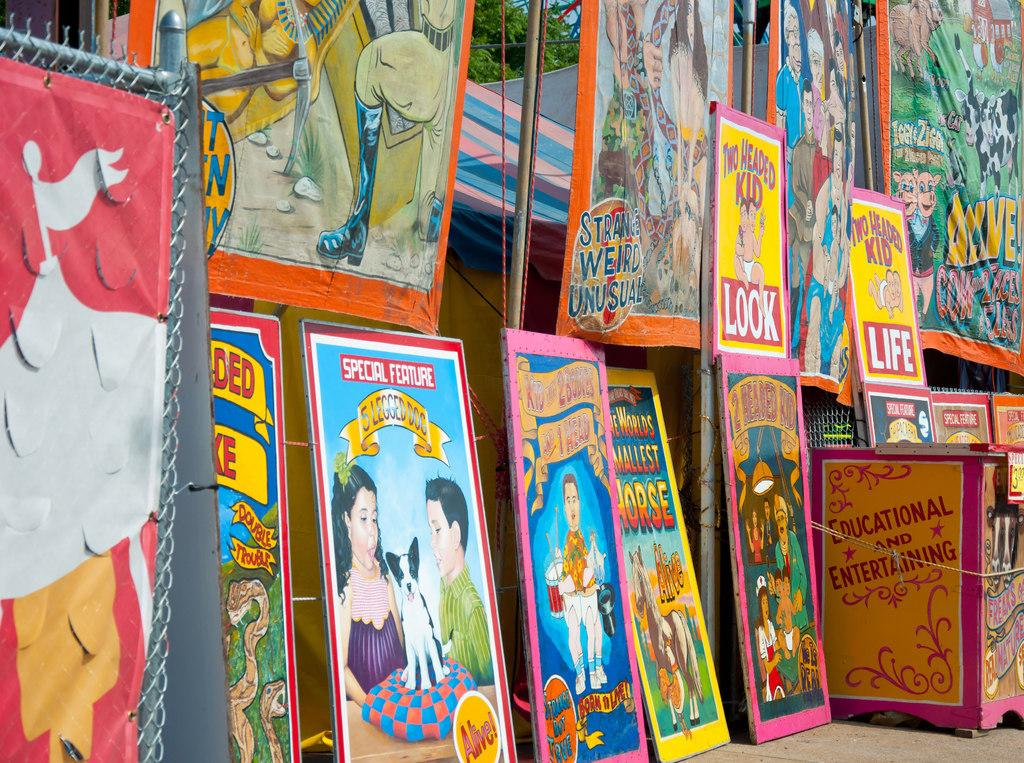<image>
Provide a brief description of the given image. Some posters, one of which has the words Special Feature Sledgedog on it. 